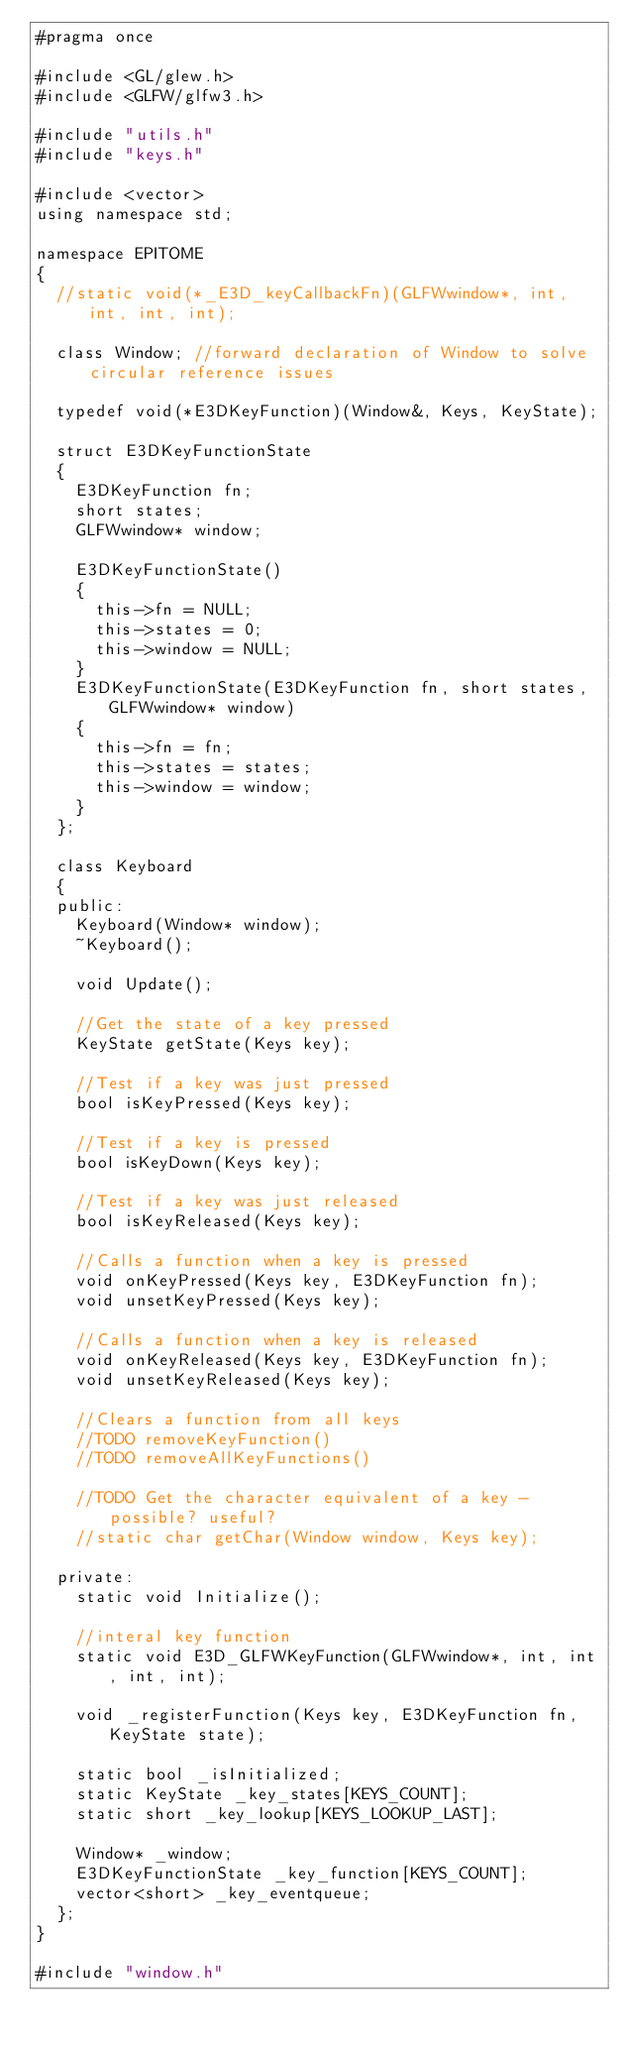Convert code to text. <code><loc_0><loc_0><loc_500><loc_500><_C_>#pragma once

#include <GL/glew.h>
#include <GLFW/glfw3.h>

#include "utils.h"
#include "keys.h"

#include <vector>
using namespace std;

namespace EPITOME
{
	//static void(*_E3D_keyCallbackFn)(GLFWwindow*, int, int, int, int);

	class Window; //forward declaration of Window to solve circular reference issues

	typedef void(*E3DKeyFunction)(Window&, Keys, KeyState);

	struct E3DKeyFunctionState
	{
		E3DKeyFunction fn;
		short states;
		GLFWwindow* window;

		E3DKeyFunctionState()
		{
			this->fn = NULL;
			this->states = 0;
			this->window = NULL;
		}
		E3DKeyFunctionState(E3DKeyFunction fn, short states, GLFWwindow* window)
		{
			this->fn = fn;
			this->states = states;
			this->window = window;
		}
	};

	class Keyboard
	{
	public:
		Keyboard(Window* window);
		~Keyboard();

		void Update();

		//Get the state of a key pressed
		KeyState getState(Keys key);

		//Test if a key was just pressed
		bool isKeyPressed(Keys key);

		//Test if a key is pressed
		bool isKeyDown(Keys key);

		//Test if a key was just released
		bool isKeyReleased(Keys key);

		//Calls a function when a key is pressed
		void onKeyPressed(Keys key, E3DKeyFunction fn);
		void unsetKeyPressed(Keys key);

		//Calls a function when a key is released
		void onKeyReleased(Keys key, E3DKeyFunction fn);
		void unsetKeyReleased(Keys key);

		//Clears a function from all keys
		//TODO removeKeyFunction()
		//TODO removeAllKeyFunctions()

		//TODO Get the character equivalent of a key - possible? useful?
		//static char getChar(Window window, Keys key);

	private:
		static void Initialize();

		//interal key function
		static void E3D_GLFWKeyFunction(GLFWwindow*, int, int, int, int);

		void _registerFunction(Keys key, E3DKeyFunction fn, KeyState state);

		static bool _isInitialized;
		static KeyState _key_states[KEYS_COUNT];
		static short _key_lookup[KEYS_LOOKUP_LAST];

		Window* _window;
		E3DKeyFunctionState _key_function[KEYS_COUNT];
		vector<short> _key_eventqueue;
	};
}

#include "window.h"</code> 